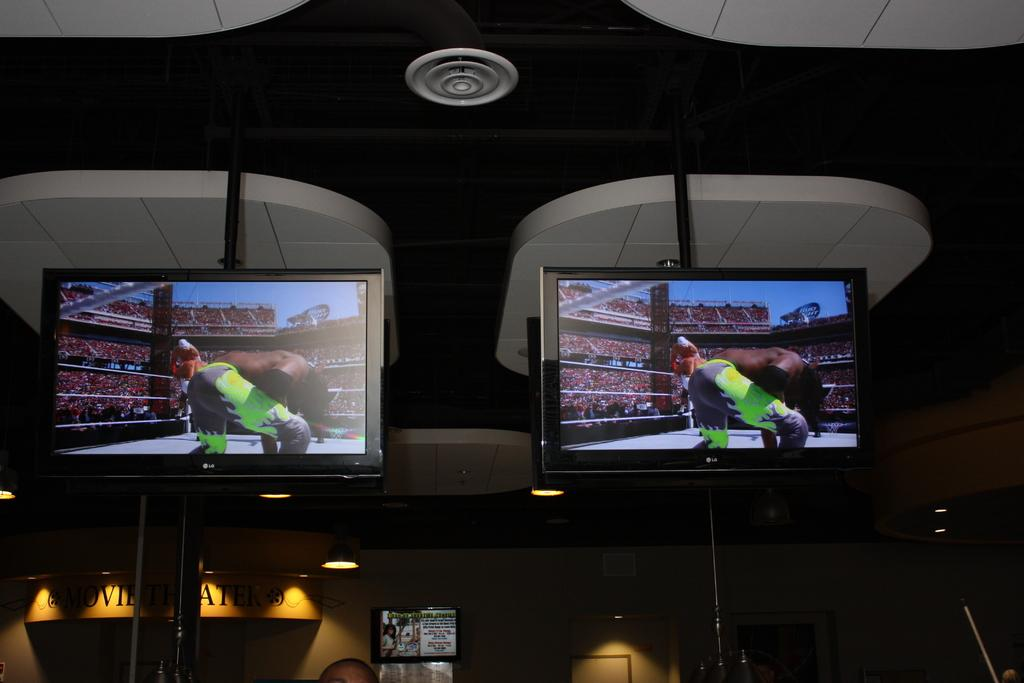<image>
Describe the image concisely. Two LG televisions are suspended from the ceiling in the interior of a building. 